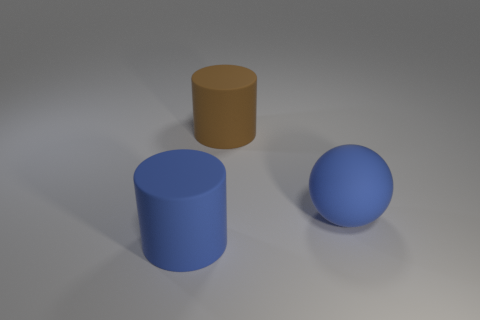Do the brown object and the blue matte thing in front of the blue matte ball have the same shape?
Ensure brevity in your answer.  Yes. Are there any big brown objects in front of the big rubber ball?
Your answer should be compact. No. What is the material of the big cylinder that is the same color as the big rubber sphere?
Provide a short and direct response. Rubber. Is the size of the blue matte cylinder the same as the cylinder behind the ball?
Make the answer very short. Yes. Is there a matte thing that has the same color as the big sphere?
Your response must be concise. Yes. Is there a blue rubber thing of the same shape as the brown matte object?
Your response must be concise. Yes. The object that is in front of the big brown matte thing and left of the blue ball has what shape?
Your response must be concise. Cylinder. What number of balls have the same material as the large brown object?
Your response must be concise. 1. Is the number of large rubber things that are behind the large brown cylinder less than the number of blue matte balls?
Offer a very short reply. Yes. There is a large object behind the matte sphere; are there any brown rubber objects left of it?
Give a very brief answer. No. 